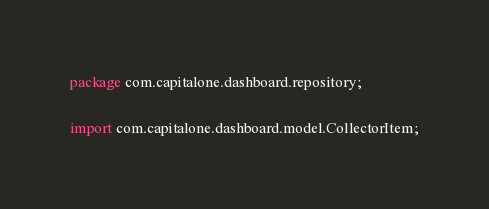<code> <loc_0><loc_0><loc_500><loc_500><_Java_>package com.capitalone.dashboard.repository;

import com.capitalone.dashboard.model.CollectorItem;</code> 